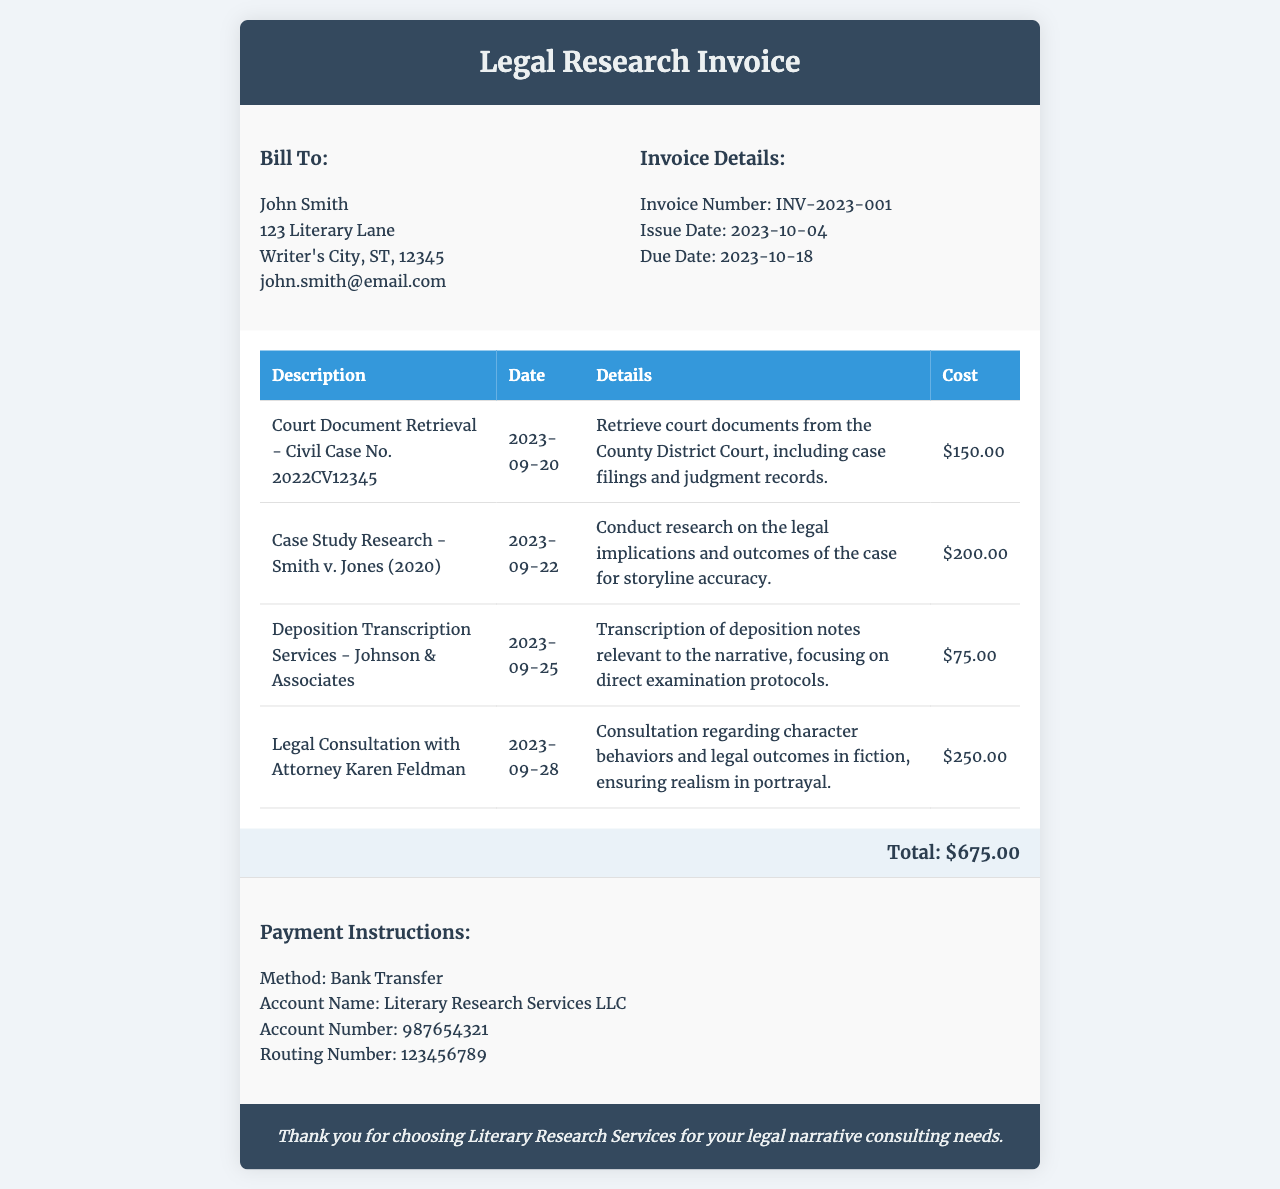What is the invoice number? The invoice number is provided in the invoice details section.
Answer: INV-2023-001 Who is the client? The client's name and details are listed in the bill to section.
Answer: John Smith What is the total cost for the legal research services? The total cost is summed up in the total section of the invoice.
Answer: $675.00 What is the date for the legal consultation with Attorney Karen Feldman? The date for the legal consultation is mentioned in the service details section.
Answer: 2023-09-28 How much was charged for case study research on Smith v. Jones? The cost for this service is listed in the cost column of the table.
Answer: $200.00 What method of payment is requested? The payment instructions section specifies the method of payment preferred.
Answer: Bank Transfer Which service had the highest cost? The services listed can be compared based on their costs, which is noted in the cost column.
Answer: Legal Consultation with Attorney Karen Feldman What is the due date for the invoice? The due date is given in the invoice details area.
Answer: 2023-10-18 Which document was retrieved for Civil Case No. 2022CV12345? The service description specifies what was retrieved in the service details section.
Answer: Court Document Retrieval 